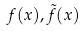<formula> <loc_0><loc_0><loc_500><loc_500>f ( x ) , \tilde { f } ( x )</formula> 